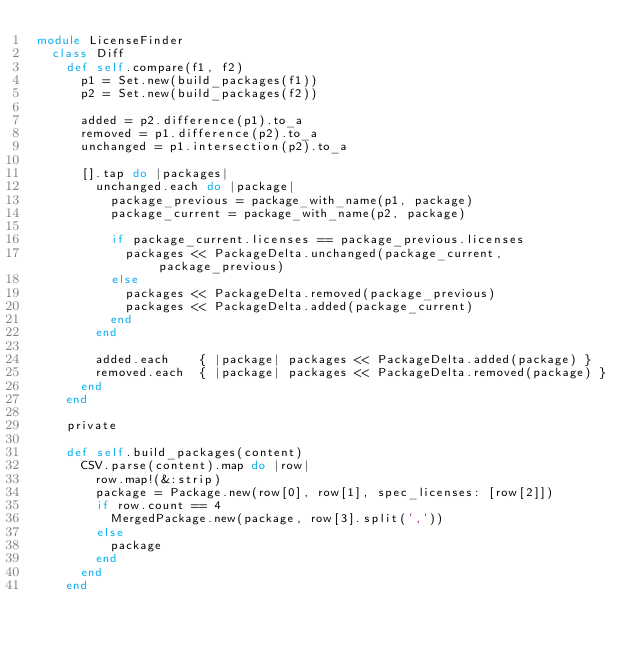<code> <loc_0><loc_0><loc_500><loc_500><_Ruby_>module LicenseFinder
  class Diff
    def self.compare(f1, f2)
      p1 = Set.new(build_packages(f1))
      p2 = Set.new(build_packages(f2))

      added = p2.difference(p1).to_a
      removed = p1.difference(p2).to_a
      unchanged = p1.intersection(p2).to_a

      [].tap do |packages|
        unchanged.each do |package|
          package_previous = package_with_name(p1, package)
          package_current = package_with_name(p2, package)

          if package_current.licenses == package_previous.licenses
            packages << PackageDelta.unchanged(package_current, package_previous)
          else
            packages << PackageDelta.removed(package_previous)
            packages << PackageDelta.added(package_current)
          end
        end

        added.each    { |package| packages << PackageDelta.added(package) }
        removed.each  { |package| packages << PackageDelta.removed(package) }
      end
    end

    private

    def self.build_packages(content)
      CSV.parse(content).map do |row|
        row.map!(&:strip)
        package = Package.new(row[0], row[1], spec_licenses: [row[2]])
        if row.count == 4
          MergedPackage.new(package, row[3].split(','))
        else
          package
        end
      end
    end
</code> 